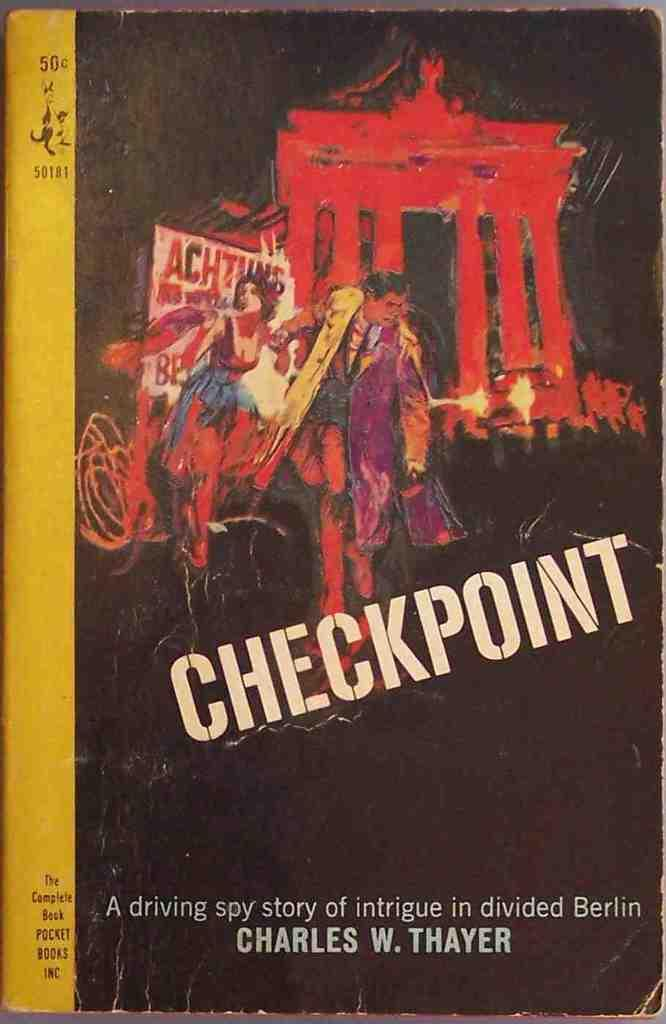<image>
Summarize the visual content of the image. A book titled Checkpoint a driving spy story of intrigue in divided Berlin by Charles W. Thayer. 